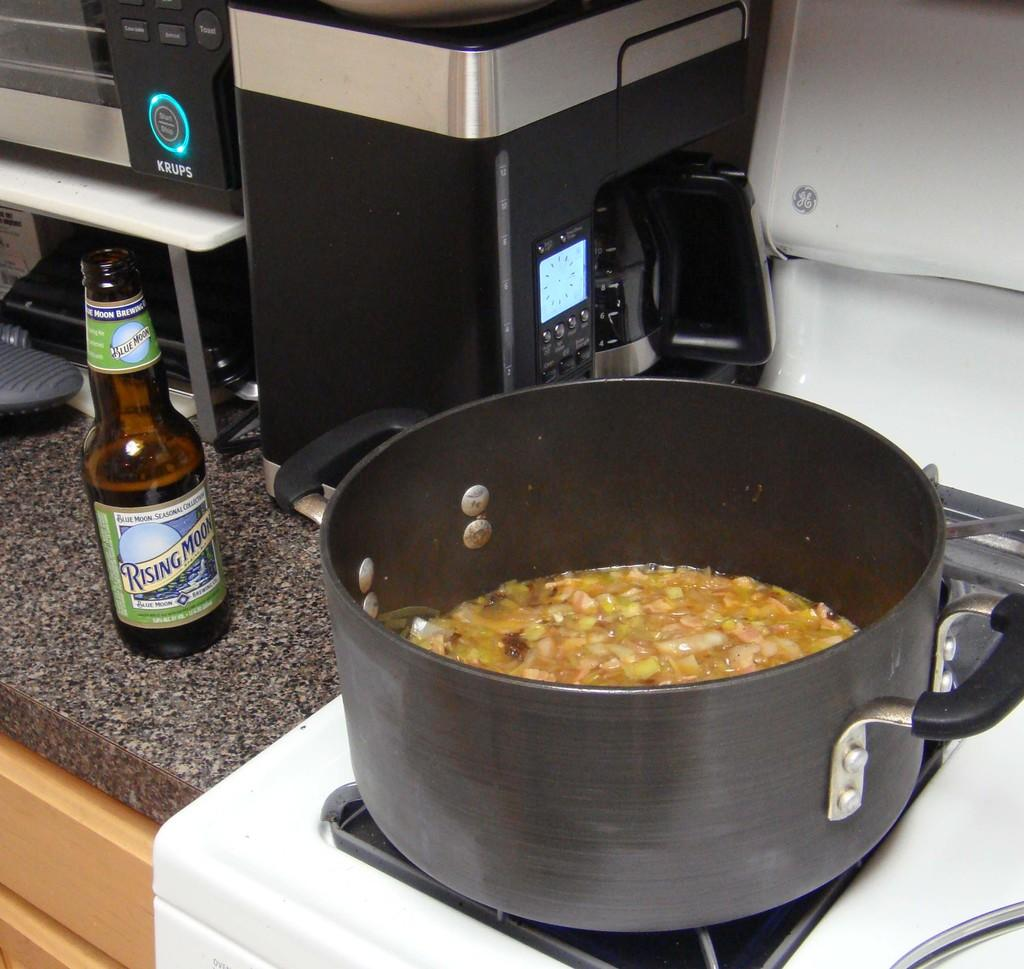<image>
Create a compact narrative representing the image presented. A pot of food is on the stove next to a bottle of Rising Moon beer on the counter. 